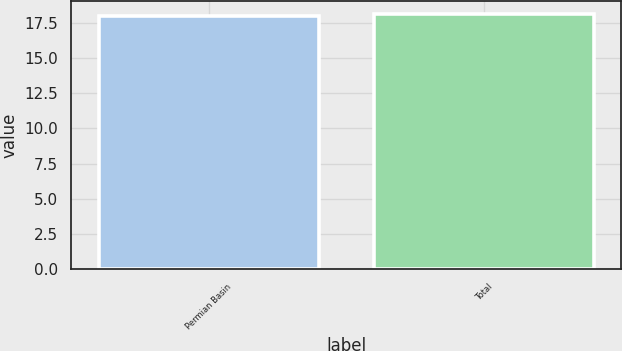Convert chart to OTSL. <chart><loc_0><loc_0><loc_500><loc_500><bar_chart><fcel>Permian Basin<fcel>Total<nl><fcel>18<fcel>18.1<nl></chart> 